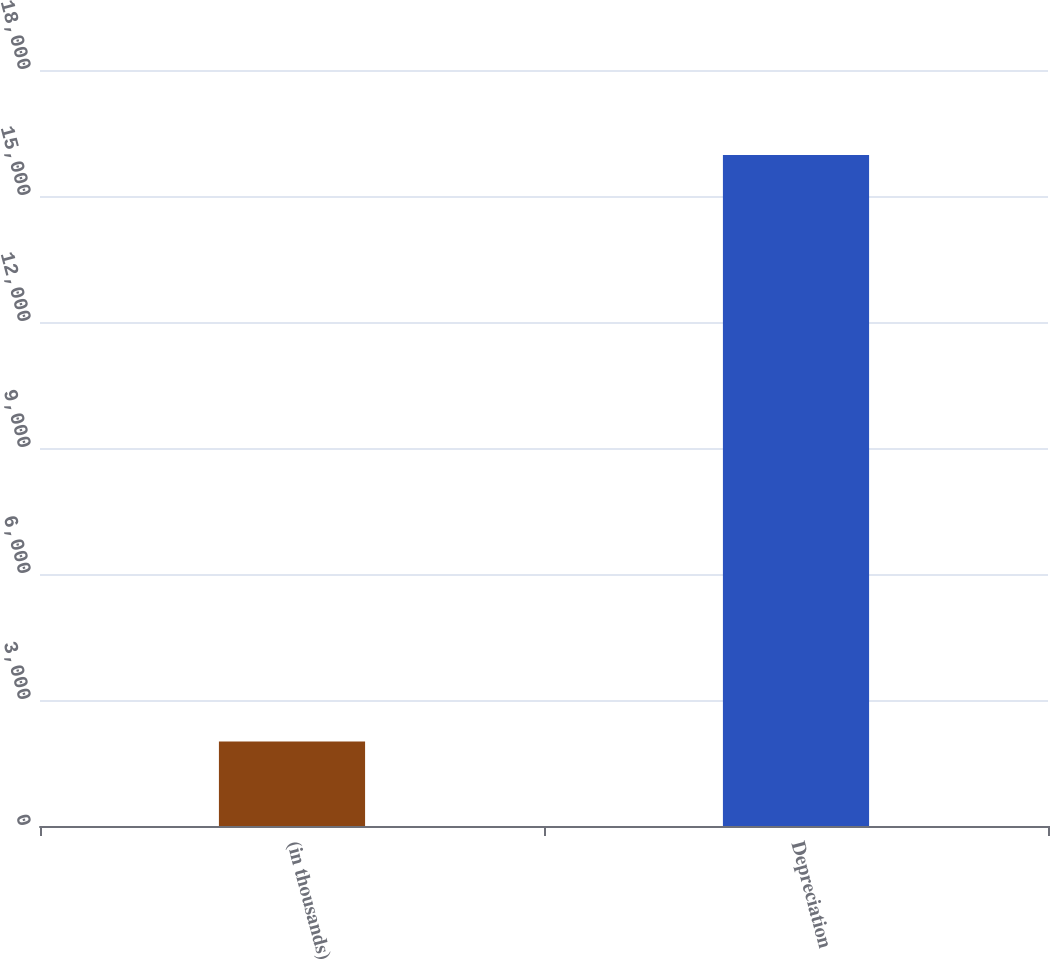Convert chart to OTSL. <chart><loc_0><loc_0><loc_500><loc_500><bar_chart><fcel>(in thousands)<fcel>Depreciation<nl><fcel>2010<fcel>15975<nl></chart> 